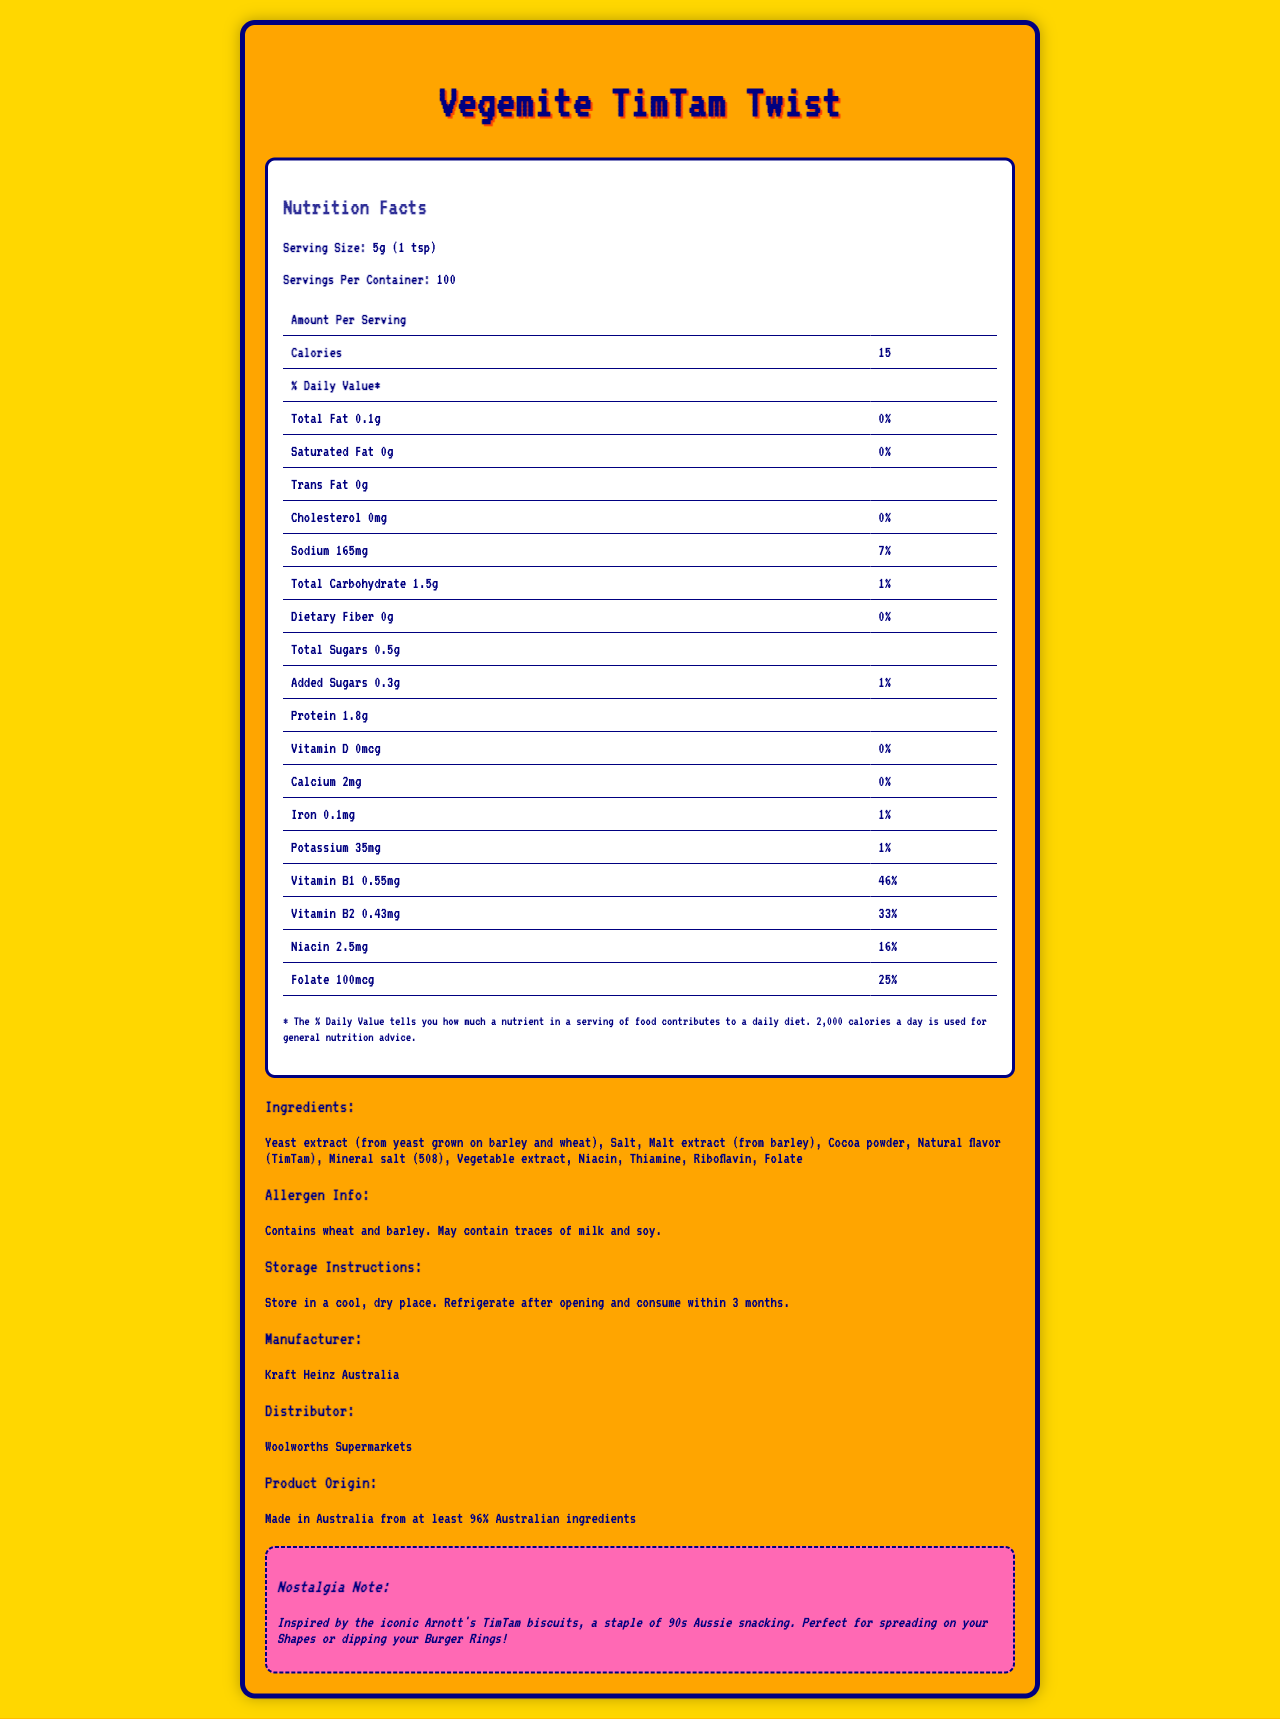what is the name of the product? The product name is clearly mentioned at the top of the document.
Answer: Vegemite TimTam Twist what is the serving size? The serving size is listed under the Nutrition Facts section in bold.
Answer: 5g (1 tsp) how many calories are in one serving? The number of calories per serving is provided in the Amount Per Serving section under Calories.
Answer: 15 which vitamin has the highest daily value percentage? Comparing all the vitamins and minerals listed, Vitamin B1 has a daily value percentage of 46%, which is the highest.
Answer: Vitamin B1 what is the total amount of fat in one serving? The total amount of fat per serving is detailed in the Nutrition Facts table.
Answer: 0.1g how much sodium is in one serving, and what is its daily value percentage? The sodium content and its daily value percentage are listed in the Nutrition Facts section.
Answer: 165mg, 7% how many servings are there per container? The amount of servings per container is stated in the Nutrition Facts section.
Answer: 100 what is the amount of added sugars per serving? The amount of added sugars is provided in the Nutrition Facts table.
Answer: 0.3g which ingredient is listed first? The ingredients are listed in descending order by weight, and yeast extract is the first item.
Answer: Yeast extract (from yeast grown on barley and wheat) does the product contain any allergens? The Allergen Info section states that the product contains wheat and barley and may contain traces of milk and soy.
Answer: Yes what should you do after opening the product? The storage instructions advise to store in a cool, dry place and refrigerate after opening.
Answer: Refrigerate after opening and consume within 3 months where is the product made? The product origin section states this information.
Answer: Made in Australia from at least 96% Australian ingredients who manufactures this product? The manufacturer is mentioned towards the end of the document.
Answer: Kraft Heinz Australia who is the distributor of the product? A. Kraft Heinz Australia B. Coles Supermarkets C. Woolworths Supermarkets The distributor section clearly lists Woolworths Supermarkets as the distributor.
Answer: C: Woolworths Supermarkets what is the daily value percentage of niacin in one serving? A. 16% B. 25% C. 33% D. 46% The daily value percentage of niacin is listed in the Nutrition Facts section as 16%.
Answer: A: 16% does the product contain cocoa powder? A. Yes B. No Cocoa powder is one of the listed ingredients.
Answer: A: Yes describe the overall document The document comprehensively describes the nutritional content, ingredients, and other relevant details of the product. The layout is visually appealing, with sections clearly delineated for easy reading.
Answer: The document is a detailed Nutrition Facts label for a limited-edition Vegemite flavor called Vegemite TimTam Twist. It includes nutritional information per serving, a list of ingredients, allergen information, storage instructions, manufacturer and distributor details, and a nostalgia note linking it to 90s Australian snacks. how much dietary fiber does the product contain? The amount of dietary fiber is listed as 0g in the Nutrition Facts table.
Answer: 0g is it safe for someone with a soy allergy to consume this product? The allergen info section states that the product may contain traces of soy, making it potentially unsafe for someone with a soy allergy.
Answer: No what is the daily value percentage for calcium? The daily value percentage for calcium is listed as 0% in the Nutrition Facts section.
Answer: 0% what is the nostalgia note related to? The nostalgia note mentions that the product is inspired by Arnott's TimTam biscuits, connects to 90s Australian snacks, and suggests uses for the Vegemite TimTam Twist.
Answer: Inspired by the iconic Arnott's TimTam biscuits, a staple of 90s Aussie snacking. Perfect for spreading on your Shapes or dipping your Burger Rings! what is the exact amount of folate in one serving? The amount of folate is listed as 100mcg in the Nutrition Facts section.
Answer: 100mcg what percent daily value of sodium does this product provide? The daily value percentage for sodium is detailed in the Nutrition Facts section as 7%.
Answer: 7% who are more likely to have tried the original snacks, Millennials or Gen Z? The document does not provide any demographic information regarding who has tried the original snacks.
Answer: Cannot be determined 